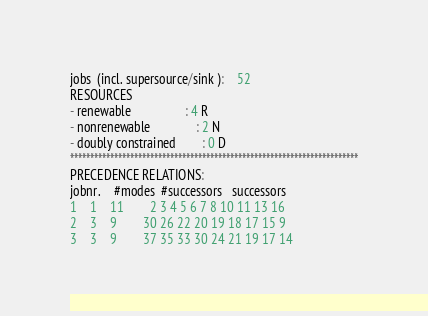<code> <loc_0><loc_0><loc_500><loc_500><_ObjectiveC_>jobs  (incl. supersource/sink ):	52
RESOURCES
- renewable                 : 4 R
- nonrenewable              : 2 N
- doubly constrained        : 0 D
************************************************************************
PRECEDENCE RELATIONS:
jobnr.    #modes  #successors   successors
1	1	11		2 3 4 5 6 7 8 10 11 13 16 
2	3	9		30 26 22 20 19 18 17 15 9 
3	3	9		37 35 33 30 24 21 19 17 14 </code> 